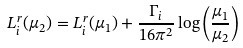<formula> <loc_0><loc_0><loc_500><loc_500>L _ { i } ^ { r } ( \mu _ { 2 } ) = L _ { i } ^ { r } ( \mu _ { 1 } ) + \frac { \Gamma _ { i } } { 1 6 \pi ^ { 2 } } \log { \left ( \frac { \mu _ { 1 } } { \mu _ { 2 } } \right ) }</formula> 